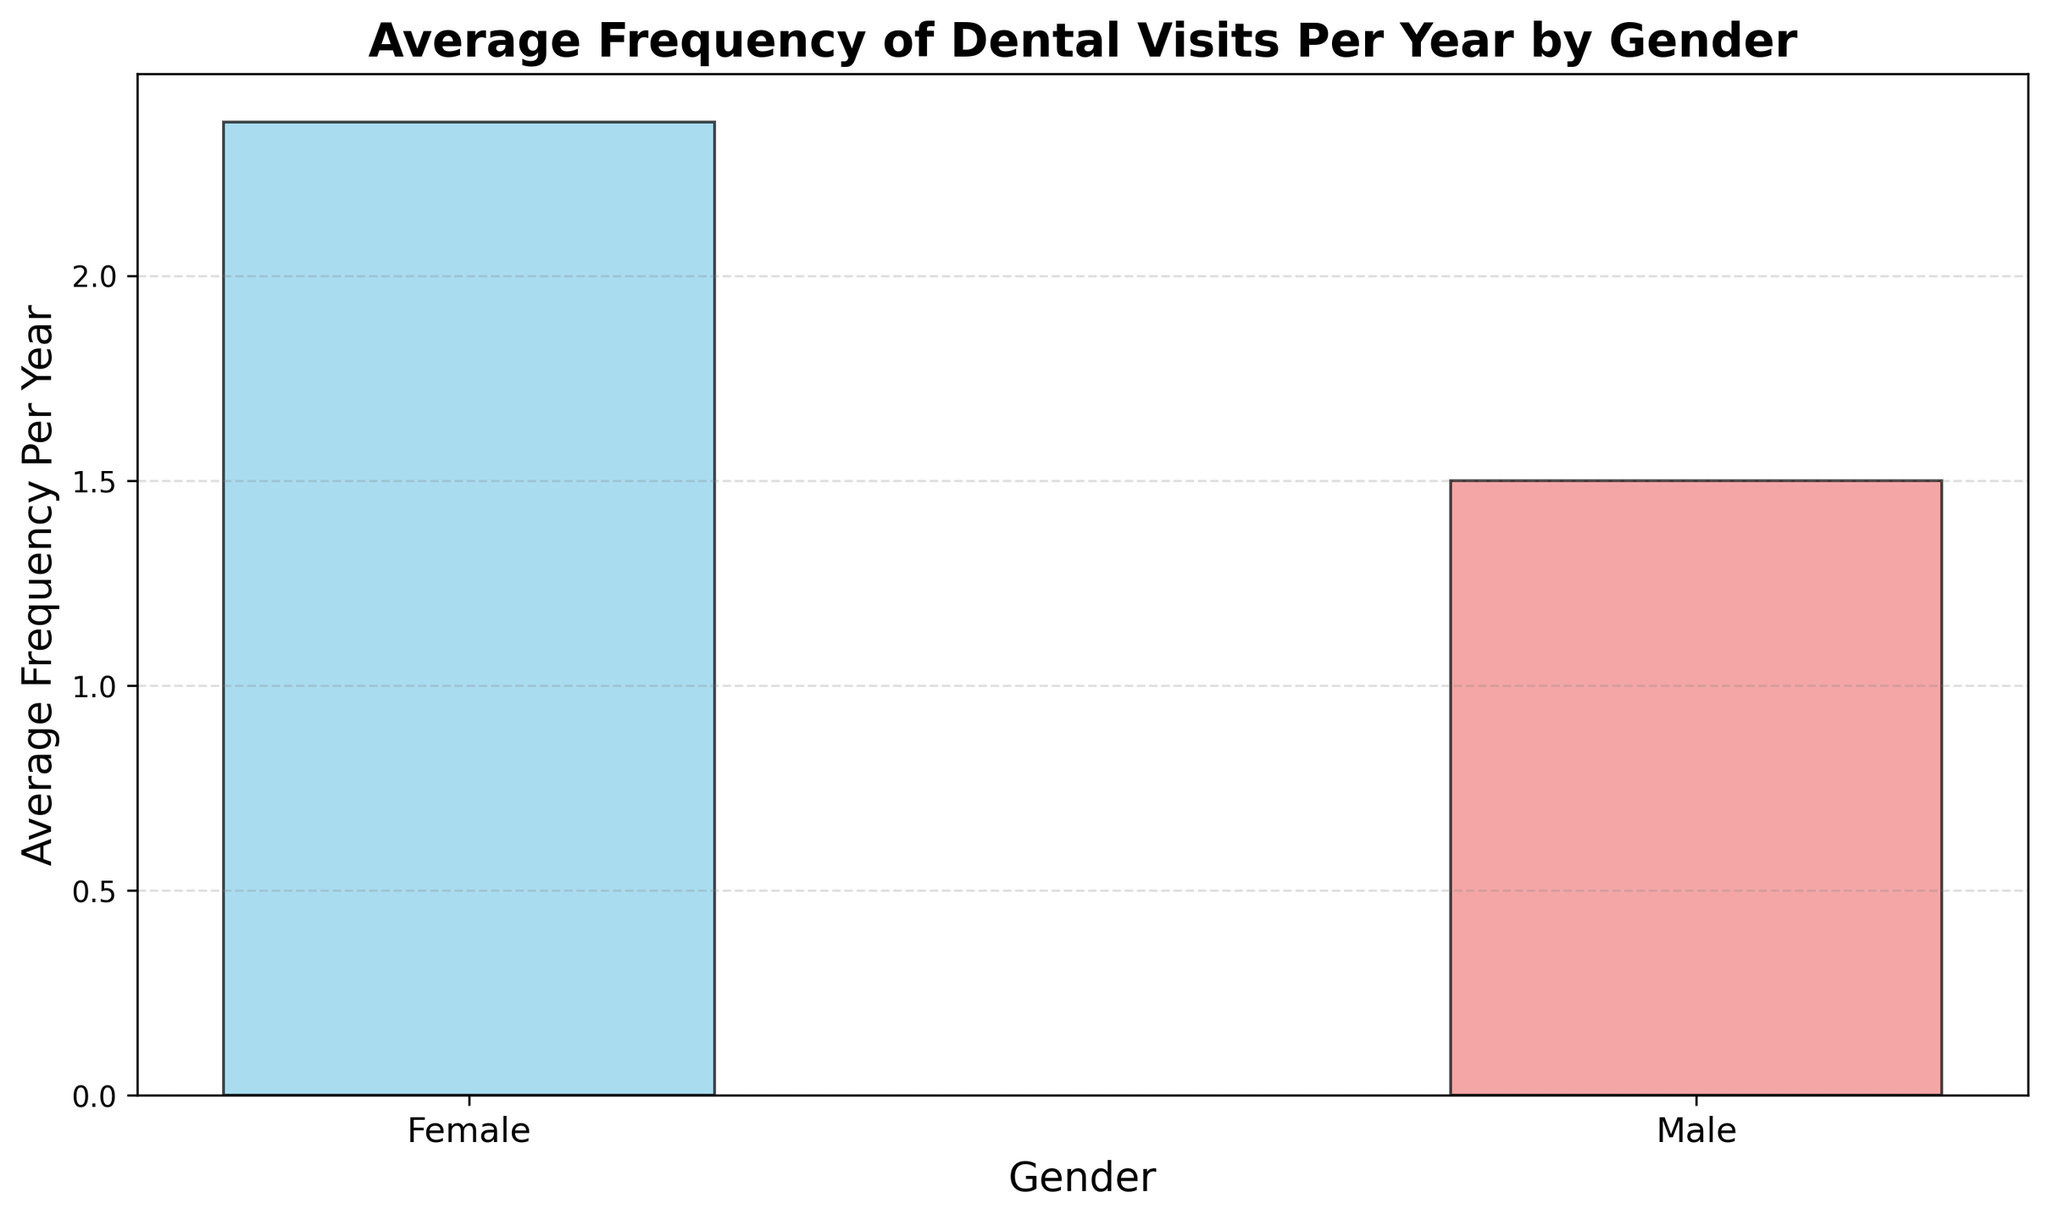What is the average frequency of dental visits per year for males? The average frequency for males is shown by the bar labeled "Male." To find this, observe the height of the bar for males on the y-axis.
Answer: 1.50 Which gender visits the dentist more frequently on average? Compare the heights of the bars for each gender. The bar for "Female" is higher than the bar for "Male," indicating a greater average frequency of visits.
Answer: Female What is the difference in average frequency of dental visits per year between males and females? Subtract the average frequency for males (1.50) from the average frequency for females (2.50) based on the bar heights.
Answer: 1.00 If a person visits the dentist twice a year, which gender are they more likely to belong to based on the average frequencies? Compare the average frequencies: males visit 1.50 times per year on average, and females visit 2.50 times per year on average. Since 2 visits are closer to the female average, they are more likely to belong to the female group.
Answer: Female How many more times on average do females visit the dentist per year than males? The difference is found by subtracting the male average frequency (1.50) from the female average frequency (2.50).
Answer: 1.00 What is the color of the bar representing males' average frequency of dental visits? Observe the color of the bar labeled "Male."
Answer: Skyblue What is the color of the bar representing females' average frequency of dental visits? Observe the color of the bar labeled "Female."
Answer: Lightcoral If you were to combine the average frequencies of dental visits for both genders and then re-calculate the average, what would the combined average be? Add the two averages (1.50 for males + 2.50 for females) and divide by 2: (1.50 + 2.50) / 2 = 2.00.
Answer: 2.00 